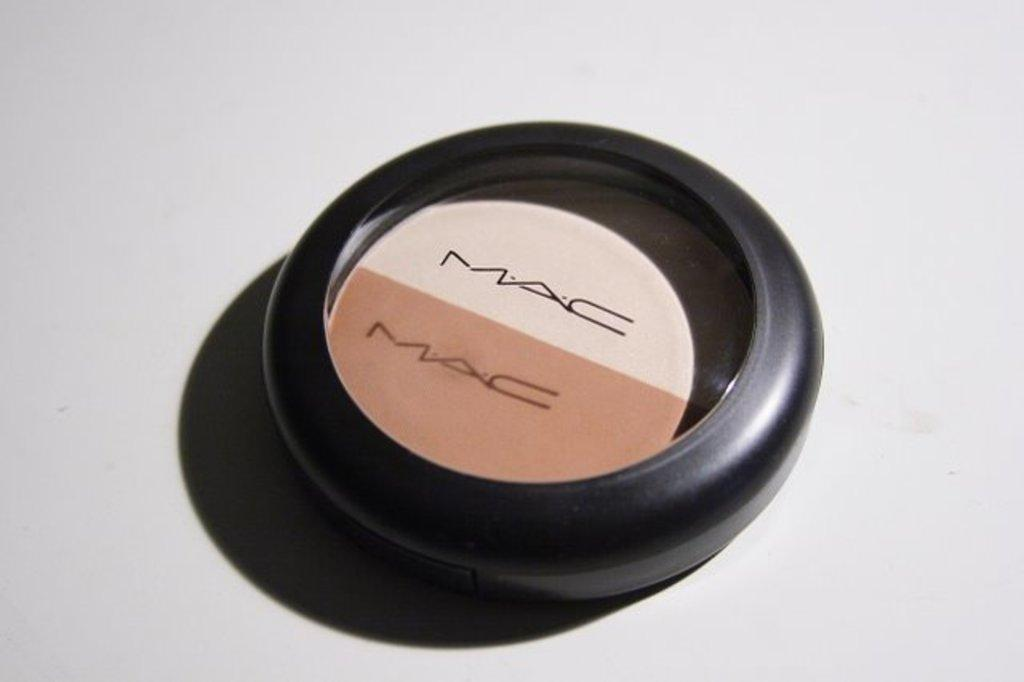What is the color of the surface in the image? The surface in the image is white. What can be found on the white surface? There is a MAC product on the white surface. Can you describe the shape of the MAC product? The MAC product is in a circular shape. How does the stranger interact with the MAC product in the image? There is no stranger present in the image, and therefore no interaction can be observed. 